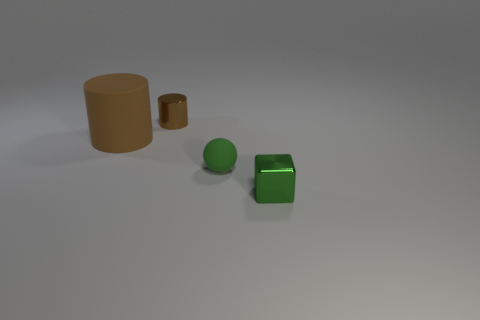Add 3 rubber blocks. How many rubber blocks exist? 3 Add 3 rubber spheres. How many objects exist? 7 Subtract 0 red blocks. How many objects are left? 4 Subtract all balls. How many objects are left? 3 Subtract all green cylinders. Subtract all cyan balls. How many cylinders are left? 2 Subtract all big purple cylinders. Subtract all tiny green things. How many objects are left? 2 Add 1 large brown cylinders. How many large brown cylinders are left? 2 